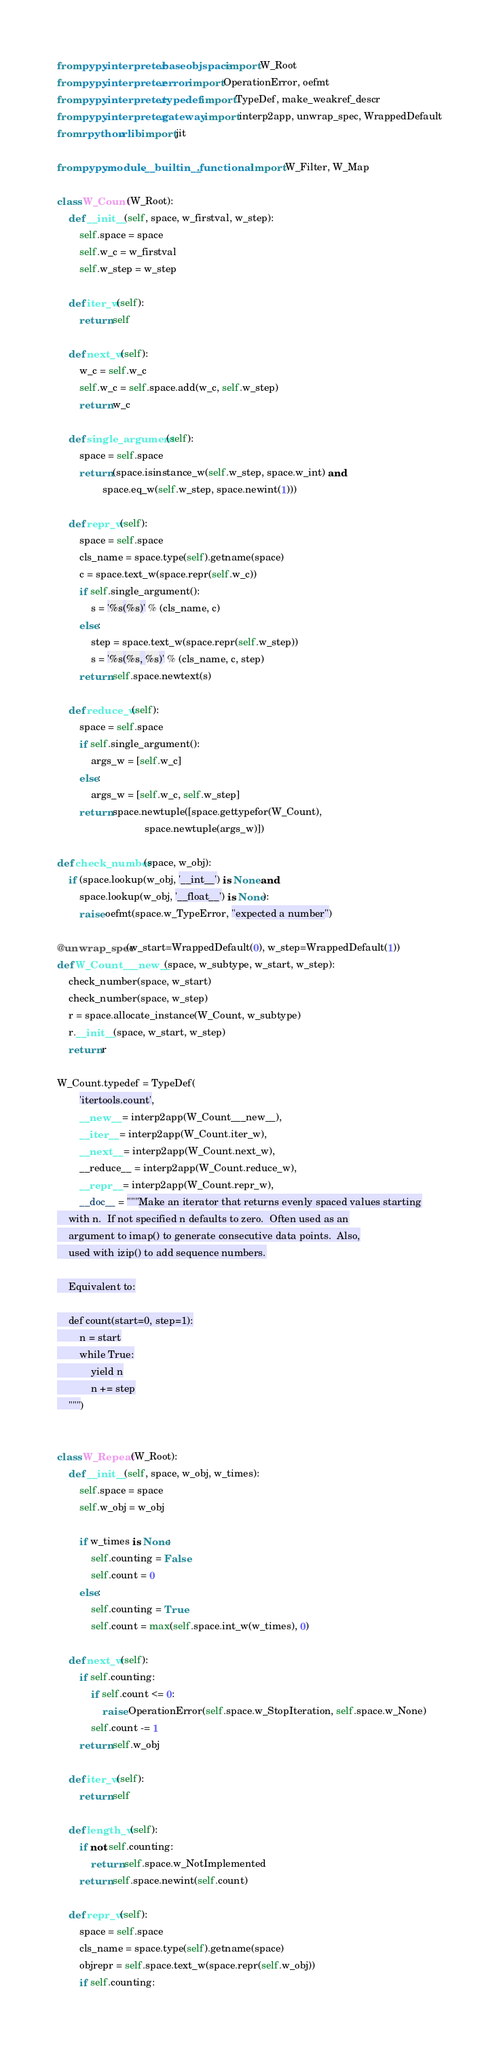<code> <loc_0><loc_0><loc_500><loc_500><_Python_>from pypy.interpreter.baseobjspace import W_Root
from pypy.interpreter.error import OperationError, oefmt
from pypy.interpreter.typedef import TypeDef, make_weakref_descr
from pypy.interpreter.gateway import interp2app, unwrap_spec, WrappedDefault
from rpython.rlib import jit

from pypy.module.__builtin__.functional import W_Filter, W_Map

class W_Count(W_Root):
    def __init__(self, space, w_firstval, w_step):
        self.space = space
        self.w_c = w_firstval
        self.w_step = w_step

    def iter_w(self):
        return self

    def next_w(self):
        w_c = self.w_c
        self.w_c = self.space.add(w_c, self.w_step)
        return w_c

    def single_argument(self):
        space = self.space
        return (space.isinstance_w(self.w_step, space.w_int) and
                space.eq_w(self.w_step, space.newint(1)))

    def repr_w(self):
        space = self.space
        cls_name = space.type(self).getname(space)
        c = space.text_w(space.repr(self.w_c))
        if self.single_argument():
            s = '%s(%s)' % (cls_name, c)
        else:
            step = space.text_w(space.repr(self.w_step))
            s = '%s(%s, %s)' % (cls_name, c, step)
        return self.space.newtext(s)

    def reduce_w(self):
        space = self.space
        if self.single_argument():
            args_w = [self.w_c]
        else:
            args_w = [self.w_c, self.w_step]
        return space.newtuple([space.gettypefor(W_Count),
                               space.newtuple(args_w)])

def check_number(space, w_obj):
    if (space.lookup(w_obj, '__int__') is None and
        space.lookup(w_obj, '__float__') is None):
        raise oefmt(space.w_TypeError, "expected a number")

@unwrap_spec(w_start=WrappedDefault(0), w_step=WrappedDefault(1))
def W_Count___new__(space, w_subtype, w_start, w_step):
    check_number(space, w_start)
    check_number(space, w_step)
    r = space.allocate_instance(W_Count, w_subtype)
    r.__init__(space, w_start, w_step)
    return r

W_Count.typedef = TypeDef(
        'itertools.count',
        __new__ = interp2app(W_Count___new__),
        __iter__ = interp2app(W_Count.iter_w),
        __next__ = interp2app(W_Count.next_w),
        __reduce__ = interp2app(W_Count.reduce_w),
        __repr__ = interp2app(W_Count.repr_w),
        __doc__ = """Make an iterator that returns evenly spaced values starting
    with n.  If not specified n defaults to zero.  Often used as an
    argument to imap() to generate consecutive data points.  Also,
    used with izip() to add sequence numbers.

    Equivalent to:

    def count(start=0, step=1):
        n = start
        while True:
            yield n
            n += step
    """)


class W_Repeat(W_Root):
    def __init__(self, space, w_obj, w_times):
        self.space = space
        self.w_obj = w_obj

        if w_times is None:
            self.counting = False
            self.count = 0
        else:
            self.counting = True
            self.count = max(self.space.int_w(w_times), 0)

    def next_w(self):
        if self.counting:
            if self.count <= 0:
                raise OperationError(self.space.w_StopIteration, self.space.w_None)
            self.count -= 1
        return self.w_obj

    def iter_w(self):
        return self

    def length_w(self):
        if not self.counting:
            return self.space.w_NotImplemented
        return self.space.newint(self.count)

    def repr_w(self):
        space = self.space
        cls_name = space.type(self).getname(space)
        objrepr = self.space.text_w(space.repr(self.w_obj))
        if self.counting:</code> 